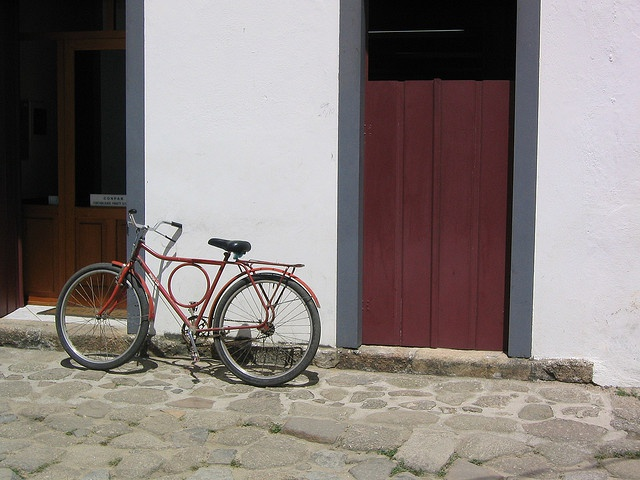Describe the objects in this image and their specific colors. I can see a bicycle in black, lightgray, gray, and darkgray tones in this image. 